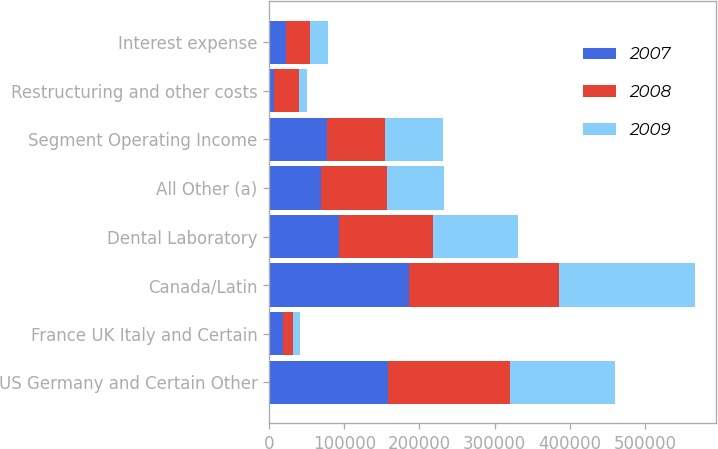Convert chart to OTSL. <chart><loc_0><loc_0><loc_500><loc_500><stacked_bar_chart><ecel><fcel>US Germany and Certain Other<fcel>France UK Italy and Certain<fcel>Canada/Latin<fcel>Dental Laboratory<fcel>All Other (a)<fcel>Segment Operating Income<fcel>Restructuring and other costs<fcel>Interest expense<nl><fcel>2007<fcel>158389<fcel>18721<fcel>185772<fcel>93569<fcel>68374<fcel>76954<fcel>6890<fcel>21896<nl><fcel>2008<fcel>162717<fcel>13017<fcel>200101<fcel>124898<fcel>87957<fcel>76954<fcel>32355<fcel>32527<nl><fcel>2009<fcel>139001<fcel>9983<fcel>180944<fcel>112444<fcel>76954<fcel>76954<fcel>10527<fcel>23783<nl></chart> 